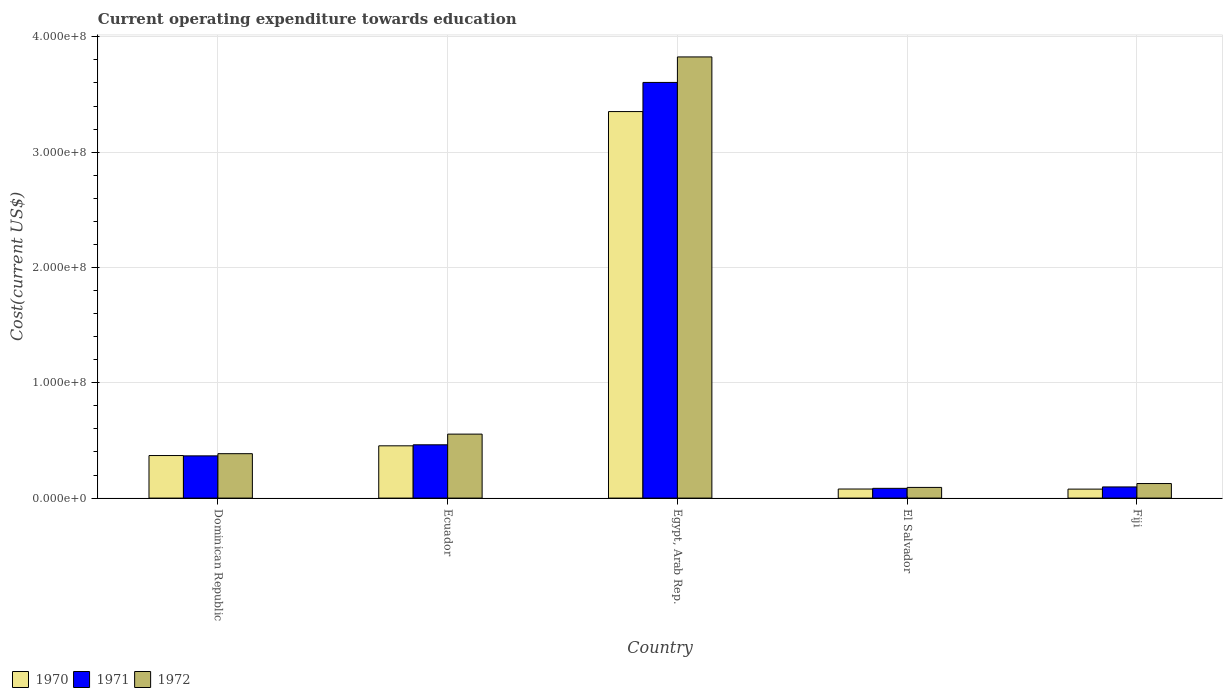Are the number of bars on each tick of the X-axis equal?
Provide a short and direct response. Yes. How many bars are there on the 3rd tick from the right?
Your answer should be very brief. 3. What is the label of the 5th group of bars from the left?
Your answer should be very brief. Fiji. In how many cases, is the number of bars for a given country not equal to the number of legend labels?
Keep it short and to the point. 0. What is the expenditure towards education in 1972 in Egypt, Arab Rep.?
Your answer should be very brief. 3.83e+08. Across all countries, what is the maximum expenditure towards education in 1970?
Keep it short and to the point. 3.35e+08. Across all countries, what is the minimum expenditure towards education in 1972?
Provide a short and direct response. 9.26e+06. In which country was the expenditure towards education in 1970 maximum?
Your response must be concise. Egypt, Arab Rep. In which country was the expenditure towards education in 1970 minimum?
Offer a terse response. Fiji. What is the total expenditure towards education in 1970 in the graph?
Your answer should be very brief. 4.33e+08. What is the difference between the expenditure towards education in 1971 in El Salvador and that in Fiji?
Offer a terse response. -1.21e+06. What is the difference between the expenditure towards education in 1970 in Dominican Republic and the expenditure towards education in 1972 in Egypt, Arab Rep.?
Make the answer very short. -3.46e+08. What is the average expenditure towards education in 1972 per country?
Provide a succinct answer. 9.97e+07. What is the difference between the expenditure towards education of/in 1972 and expenditure towards education of/in 1970 in Fiji?
Offer a terse response. 4.84e+06. In how many countries, is the expenditure towards education in 1970 greater than 220000000 US$?
Give a very brief answer. 1. What is the ratio of the expenditure towards education in 1971 in Ecuador to that in Egypt, Arab Rep.?
Provide a succinct answer. 0.13. Is the difference between the expenditure towards education in 1972 in Dominican Republic and Ecuador greater than the difference between the expenditure towards education in 1970 in Dominican Republic and Ecuador?
Offer a very short reply. No. What is the difference between the highest and the second highest expenditure towards education in 1970?
Your answer should be compact. 2.90e+08. What is the difference between the highest and the lowest expenditure towards education in 1971?
Offer a very short reply. 3.52e+08. Is the sum of the expenditure towards education in 1970 in Egypt, Arab Rep. and El Salvador greater than the maximum expenditure towards education in 1971 across all countries?
Ensure brevity in your answer.  No. What does the 1st bar from the left in El Salvador represents?
Your answer should be very brief. 1970. How many countries are there in the graph?
Offer a terse response. 5. What is the difference between two consecutive major ticks on the Y-axis?
Provide a short and direct response. 1.00e+08. What is the title of the graph?
Your response must be concise. Current operating expenditure towards education. Does "1983" appear as one of the legend labels in the graph?
Provide a short and direct response. No. What is the label or title of the X-axis?
Offer a terse response. Country. What is the label or title of the Y-axis?
Provide a succinct answer. Cost(current US$). What is the Cost(current US$) of 1970 in Dominican Republic?
Your response must be concise. 3.69e+07. What is the Cost(current US$) of 1971 in Dominican Republic?
Your response must be concise. 3.66e+07. What is the Cost(current US$) in 1972 in Dominican Republic?
Keep it short and to the point. 3.85e+07. What is the Cost(current US$) of 1970 in Ecuador?
Give a very brief answer. 4.53e+07. What is the Cost(current US$) of 1971 in Ecuador?
Provide a short and direct response. 4.62e+07. What is the Cost(current US$) of 1972 in Ecuador?
Provide a short and direct response. 5.55e+07. What is the Cost(current US$) of 1970 in Egypt, Arab Rep.?
Offer a terse response. 3.35e+08. What is the Cost(current US$) of 1971 in Egypt, Arab Rep.?
Provide a short and direct response. 3.60e+08. What is the Cost(current US$) of 1972 in Egypt, Arab Rep.?
Make the answer very short. 3.83e+08. What is the Cost(current US$) in 1970 in El Salvador?
Offer a terse response. 7.86e+06. What is the Cost(current US$) in 1971 in El Salvador?
Your answer should be very brief. 8.46e+06. What is the Cost(current US$) in 1972 in El Salvador?
Offer a terse response. 9.26e+06. What is the Cost(current US$) in 1970 in Fiji?
Your answer should be compact. 7.79e+06. What is the Cost(current US$) of 1971 in Fiji?
Make the answer very short. 9.67e+06. What is the Cost(current US$) in 1972 in Fiji?
Your response must be concise. 1.26e+07. Across all countries, what is the maximum Cost(current US$) of 1970?
Provide a succinct answer. 3.35e+08. Across all countries, what is the maximum Cost(current US$) of 1971?
Offer a very short reply. 3.60e+08. Across all countries, what is the maximum Cost(current US$) of 1972?
Your response must be concise. 3.83e+08. Across all countries, what is the minimum Cost(current US$) of 1970?
Provide a short and direct response. 7.79e+06. Across all countries, what is the minimum Cost(current US$) in 1971?
Provide a short and direct response. 8.46e+06. Across all countries, what is the minimum Cost(current US$) in 1972?
Ensure brevity in your answer.  9.26e+06. What is the total Cost(current US$) in 1970 in the graph?
Your response must be concise. 4.33e+08. What is the total Cost(current US$) of 1971 in the graph?
Offer a very short reply. 4.61e+08. What is the total Cost(current US$) in 1972 in the graph?
Your answer should be compact. 4.98e+08. What is the difference between the Cost(current US$) in 1970 in Dominican Republic and that in Ecuador?
Make the answer very short. -8.43e+06. What is the difference between the Cost(current US$) of 1971 in Dominican Republic and that in Ecuador?
Provide a succinct answer. -9.60e+06. What is the difference between the Cost(current US$) of 1972 in Dominican Republic and that in Ecuador?
Your answer should be very brief. -1.70e+07. What is the difference between the Cost(current US$) of 1970 in Dominican Republic and that in Egypt, Arab Rep.?
Provide a short and direct response. -2.98e+08. What is the difference between the Cost(current US$) of 1971 in Dominican Republic and that in Egypt, Arab Rep.?
Provide a succinct answer. -3.24e+08. What is the difference between the Cost(current US$) of 1972 in Dominican Republic and that in Egypt, Arab Rep.?
Offer a terse response. -3.44e+08. What is the difference between the Cost(current US$) of 1970 in Dominican Republic and that in El Salvador?
Provide a short and direct response. 2.90e+07. What is the difference between the Cost(current US$) of 1971 in Dominican Republic and that in El Salvador?
Your answer should be compact. 2.82e+07. What is the difference between the Cost(current US$) of 1972 in Dominican Republic and that in El Salvador?
Offer a very short reply. 2.93e+07. What is the difference between the Cost(current US$) in 1970 in Dominican Republic and that in Fiji?
Offer a terse response. 2.91e+07. What is the difference between the Cost(current US$) of 1971 in Dominican Republic and that in Fiji?
Offer a terse response. 2.69e+07. What is the difference between the Cost(current US$) in 1972 in Dominican Republic and that in Fiji?
Provide a short and direct response. 2.59e+07. What is the difference between the Cost(current US$) in 1970 in Ecuador and that in Egypt, Arab Rep.?
Your answer should be very brief. -2.90e+08. What is the difference between the Cost(current US$) in 1971 in Ecuador and that in Egypt, Arab Rep.?
Give a very brief answer. -3.14e+08. What is the difference between the Cost(current US$) of 1972 in Ecuador and that in Egypt, Arab Rep.?
Keep it short and to the point. -3.27e+08. What is the difference between the Cost(current US$) of 1970 in Ecuador and that in El Salvador?
Ensure brevity in your answer.  3.75e+07. What is the difference between the Cost(current US$) in 1971 in Ecuador and that in El Salvador?
Make the answer very short. 3.78e+07. What is the difference between the Cost(current US$) in 1972 in Ecuador and that in El Salvador?
Your response must be concise. 4.62e+07. What is the difference between the Cost(current US$) in 1970 in Ecuador and that in Fiji?
Your answer should be compact. 3.75e+07. What is the difference between the Cost(current US$) of 1971 in Ecuador and that in Fiji?
Make the answer very short. 3.65e+07. What is the difference between the Cost(current US$) of 1972 in Ecuador and that in Fiji?
Offer a terse response. 4.29e+07. What is the difference between the Cost(current US$) in 1970 in Egypt, Arab Rep. and that in El Salvador?
Your response must be concise. 3.27e+08. What is the difference between the Cost(current US$) of 1971 in Egypt, Arab Rep. and that in El Salvador?
Ensure brevity in your answer.  3.52e+08. What is the difference between the Cost(current US$) of 1972 in Egypt, Arab Rep. and that in El Salvador?
Ensure brevity in your answer.  3.73e+08. What is the difference between the Cost(current US$) in 1970 in Egypt, Arab Rep. and that in Fiji?
Ensure brevity in your answer.  3.27e+08. What is the difference between the Cost(current US$) in 1971 in Egypt, Arab Rep. and that in Fiji?
Keep it short and to the point. 3.51e+08. What is the difference between the Cost(current US$) of 1972 in Egypt, Arab Rep. and that in Fiji?
Provide a succinct answer. 3.70e+08. What is the difference between the Cost(current US$) in 1970 in El Salvador and that in Fiji?
Offer a very short reply. 7.56e+04. What is the difference between the Cost(current US$) of 1971 in El Salvador and that in Fiji?
Offer a very short reply. -1.21e+06. What is the difference between the Cost(current US$) of 1972 in El Salvador and that in Fiji?
Give a very brief answer. -3.37e+06. What is the difference between the Cost(current US$) in 1970 in Dominican Republic and the Cost(current US$) in 1971 in Ecuador?
Provide a succinct answer. -9.31e+06. What is the difference between the Cost(current US$) in 1970 in Dominican Republic and the Cost(current US$) in 1972 in Ecuador?
Offer a terse response. -1.86e+07. What is the difference between the Cost(current US$) of 1971 in Dominican Republic and the Cost(current US$) of 1972 in Ecuador?
Offer a very short reply. -1.89e+07. What is the difference between the Cost(current US$) in 1970 in Dominican Republic and the Cost(current US$) in 1971 in Egypt, Arab Rep.?
Make the answer very short. -3.24e+08. What is the difference between the Cost(current US$) in 1970 in Dominican Republic and the Cost(current US$) in 1972 in Egypt, Arab Rep.?
Offer a very short reply. -3.46e+08. What is the difference between the Cost(current US$) in 1971 in Dominican Republic and the Cost(current US$) in 1972 in Egypt, Arab Rep.?
Offer a very short reply. -3.46e+08. What is the difference between the Cost(current US$) of 1970 in Dominican Republic and the Cost(current US$) of 1971 in El Salvador?
Offer a terse response. 2.84e+07. What is the difference between the Cost(current US$) of 1970 in Dominican Republic and the Cost(current US$) of 1972 in El Salvador?
Offer a terse response. 2.76e+07. What is the difference between the Cost(current US$) in 1971 in Dominican Republic and the Cost(current US$) in 1972 in El Salvador?
Offer a terse response. 2.74e+07. What is the difference between the Cost(current US$) in 1970 in Dominican Republic and the Cost(current US$) in 1971 in Fiji?
Your response must be concise. 2.72e+07. What is the difference between the Cost(current US$) in 1970 in Dominican Republic and the Cost(current US$) in 1972 in Fiji?
Keep it short and to the point. 2.43e+07. What is the difference between the Cost(current US$) in 1971 in Dominican Republic and the Cost(current US$) in 1972 in Fiji?
Offer a terse response. 2.40e+07. What is the difference between the Cost(current US$) of 1970 in Ecuador and the Cost(current US$) of 1971 in Egypt, Arab Rep.?
Your answer should be very brief. -3.15e+08. What is the difference between the Cost(current US$) of 1970 in Ecuador and the Cost(current US$) of 1972 in Egypt, Arab Rep.?
Your response must be concise. -3.37e+08. What is the difference between the Cost(current US$) of 1971 in Ecuador and the Cost(current US$) of 1972 in Egypt, Arab Rep.?
Offer a very short reply. -3.36e+08. What is the difference between the Cost(current US$) in 1970 in Ecuador and the Cost(current US$) in 1971 in El Salvador?
Offer a very short reply. 3.69e+07. What is the difference between the Cost(current US$) in 1970 in Ecuador and the Cost(current US$) in 1972 in El Salvador?
Ensure brevity in your answer.  3.61e+07. What is the difference between the Cost(current US$) in 1971 in Ecuador and the Cost(current US$) in 1972 in El Salvador?
Your response must be concise. 3.70e+07. What is the difference between the Cost(current US$) of 1970 in Ecuador and the Cost(current US$) of 1971 in Fiji?
Give a very brief answer. 3.57e+07. What is the difference between the Cost(current US$) of 1970 in Ecuador and the Cost(current US$) of 1972 in Fiji?
Offer a terse response. 3.27e+07. What is the difference between the Cost(current US$) in 1971 in Ecuador and the Cost(current US$) in 1972 in Fiji?
Keep it short and to the point. 3.36e+07. What is the difference between the Cost(current US$) of 1970 in Egypt, Arab Rep. and the Cost(current US$) of 1971 in El Salvador?
Your response must be concise. 3.27e+08. What is the difference between the Cost(current US$) in 1970 in Egypt, Arab Rep. and the Cost(current US$) in 1972 in El Salvador?
Offer a very short reply. 3.26e+08. What is the difference between the Cost(current US$) in 1971 in Egypt, Arab Rep. and the Cost(current US$) in 1972 in El Salvador?
Offer a terse response. 3.51e+08. What is the difference between the Cost(current US$) of 1970 in Egypt, Arab Rep. and the Cost(current US$) of 1971 in Fiji?
Provide a short and direct response. 3.26e+08. What is the difference between the Cost(current US$) of 1970 in Egypt, Arab Rep. and the Cost(current US$) of 1972 in Fiji?
Your response must be concise. 3.23e+08. What is the difference between the Cost(current US$) of 1971 in Egypt, Arab Rep. and the Cost(current US$) of 1972 in Fiji?
Your answer should be compact. 3.48e+08. What is the difference between the Cost(current US$) in 1970 in El Salvador and the Cost(current US$) in 1971 in Fiji?
Provide a short and direct response. -1.81e+06. What is the difference between the Cost(current US$) of 1970 in El Salvador and the Cost(current US$) of 1972 in Fiji?
Offer a terse response. -4.76e+06. What is the difference between the Cost(current US$) of 1971 in El Salvador and the Cost(current US$) of 1972 in Fiji?
Your answer should be very brief. -4.16e+06. What is the average Cost(current US$) in 1970 per country?
Your answer should be compact. 8.66e+07. What is the average Cost(current US$) of 1971 per country?
Provide a short and direct response. 9.23e+07. What is the average Cost(current US$) of 1972 per country?
Your answer should be very brief. 9.97e+07. What is the difference between the Cost(current US$) in 1970 and Cost(current US$) in 1971 in Dominican Republic?
Provide a short and direct response. 2.90e+05. What is the difference between the Cost(current US$) in 1970 and Cost(current US$) in 1972 in Dominican Republic?
Provide a short and direct response. -1.61e+06. What is the difference between the Cost(current US$) of 1971 and Cost(current US$) of 1972 in Dominican Republic?
Your response must be concise. -1.90e+06. What is the difference between the Cost(current US$) in 1970 and Cost(current US$) in 1971 in Ecuador?
Your answer should be compact. -8.82e+05. What is the difference between the Cost(current US$) of 1970 and Cost(current US$) of 1972 in Ecuador?
Your answer should be compact. -1.02e+07. What is the difference between the Cost(current US$) in 1971 and Cost(current US$) in 1972 in Ecuador?
Offer a terse response. -9.27e+06. What is the difference between the Cost(current US$) of 1970 and Cost(current US$) of 1971 in Egypt, Arab Rep.?
Keep it short and to the point. -2.53e+07. What is the difference between the Cost(current US$) in 1970 and Cost(current US$) in 1972 in Egypt, Arab Rep.?
Your answer should be compact. -4.74e+07. What is the difference between the Cost(current US$) of 1971 and Cost(current US$) of 1972 in Egypt, Arab Rep.?
Provide a short and direct response. -2.21e+07. What is the difference between the Cost(current US$) of 1970 and Cost(current US$) of 1971 in El Salvador?
Make the answer very short. -6.00e+05. What is the difference between the Cost(current US$) in 1970 and Cost(current US$) in 1972 in El Salvador?
Offer a very short reply. -1.39e+06. What is the difference between the Cost(current US$) of 1971 and Cost(current US$) of 1972 in El Salvador?
Give a very brief answer. -7.94e+05. What is the difference between the Cost(current US$) in 1970 and Cost(current US$) in 1971 in Fiji?
Your answer should be compact. -1.89e+06. What is the difference between the Cost(current US$) of 1970 and Cost(current US$) of 1972 in Fiji?
Your answer should be very brief. -4.84e+06. What is the difference between the Cost(current US$) in 1971 and Cost(current US$) in 1972 in Fiji?
Provide a succinct answer. -2.95e+06. What is the ratio of the Cost(current US$) in 1970 in Dominican Republic to that in Ecuador?
Your answer should be compact. 0.81. What is the ratio of the Cost(current US$) in 1971 in Dominican Republic to that in Ecuador?
Provide a succinct answer. 0.79. What is the ratio of the Cost(current US$) in 1972 in Dominican Republic to that in Ecuador?
Your answer should be very brief. 0.69. What is the ratio of the Cost(current US$) in 1970 in Dominican Republic to that in Egypt, Arab Rep.?
Your answer should be very brief. 0.11. What is the ratio of the Cost(current US$) of 1971 in Dominican Republic to that in Egypt, Arab Rep.?
Give a very brief answer. 0.1. What is the ratio of the Cost(current US$) in 1972 in Dominican Republic to that in Egypt, Arab Rep.?
Provide a short and direct response. 0.1. What is the ratio of the Cost(current US$) in 1970 in Dominican Republic to that in El Salvador?
Offer a very short reply. 4.69. What is the ratio of the Cost(current US$) of 1971 in Dominican Republic to that in El Salvador?
Keep it short and to the point. 4.33. What is the ratio of the Cost(current US$) of 1972 in Dominican Republic to that in El Salvador?
Offer a very short reply. 4.16. What is the ratio of the Cost(current US$) in 1970 in Dominican Republic to that in Fiji?
Offer a very short reply. 4.74. What is the ratio of the Cost(current US$) of 1971 in Dominican Republic to that in Fiji?
Provide a short and direct response. 3.79. What is the ratio of the Cost(current US$) of 1972 in Dominican Republic to that in Fiji?
Make the answer very short. 3.05. What is the ratio of the Cost(current US$) of 1970 in Ecuador to that in Egypt, Arab Rep.?
Provide a short and direct response. 0.14. What is the ratio of the Cost(current US$) in 1971 in Ecuador to that in Egypt, Arab Rep.?
Your response must be concise. 0.13. What is the ratio of the Cost(current US$) in 1972 in Ecuador to that in Egypt, Arab Rep.?
Your answer should be very brief. 0.14. What is the ratio of the Cost(current US$) of 1970 in Ecuador to that in El Salvador?
Provide a short and direct response. 5.77. What is the ratio of the Cost(current US$) in 1971 in Ecuador to that in El Salvador?
Give a very brief answer. 5.46. What is the ratio of the Cost(current US$) of 1972 in Ecuador to that in El Salvador?
Offer a very short reply. 5.99. What is the ratio of the Cost(current US$) in 1970 in Ecuador to that in Fiji?
Ensure brevity in your answer.  5.82. What is the ratio of the Cost(current US$) of 1971 in Ecuador to that in Fiji?
Offer a very short reply. 4.78. What is the ratio of the Cost(current US$) in 1972 in Ecuador to that in Fiji?
Offer a terse response. 4.39. What is the ratio of the Cost(current US$) in 1970 in Egypt, Arab Rep. to that in El Salvador?
Your answer should be very brief. 42.63. What is the ratio of the Cost(current US$) of 1971 in Egypt, Arab Rep. to that in El Salvador?
Your response must be concise. 42.59. What is the ratio of the Cost(current US$) in 1972 in Egypt, Arab Rep. to that in El Salvador?
Provide a succinct answer. 41.33. What is the ratio of the Cost(current US$) in 1970 in Egypt, Arab Rep. to that in Fiji?
Your answer should be very brief. 43.04. What is the ratio of the Cost(current US$) of 1971 in Egypt, Arab Rep. to that in Fiji?
Provide a succinct answer. 37.26. What is the ratio of the Cost(current US$) of 1972 in Egypt, Arab Rep. to that in Fiji?
Offer a very short reply. 30.3. What is the ratio of the Cost(current US$) in 1970 in El Salvador to that in Fiji?
Provide a short and direct response. 1.01. What is the ratio of the Cost(current US$) of 1971 in El Salvador to that in Fiji?
Offer a terse response. 0.87. What is the ratio of the Cost(current US$) in 1972 in El Salvador to that in Fiji?
Your answer should be very brief. 0.73. What is the difference between the highest and the second highest Cost(current US$) of 1970?
Offer a very short reply. 2.90e+08. What is the difference between the highest and the second highest Cost(current US$) of 1971?
Offer a terse response. 3.14e+08. What is the difference between the highest and the second highest Cost(current US$) in 1972?
Offer a very short reply. 3.27e+08. What is the difference between the highest and the lowest Cost(current US$) of 1970?
Give a very brief answer. 3.27e+08. What is the difference between the highest and the lowest Cost(current US$) in 1971?
Ensure brevity in your answer.  3.52e+08. What is the difference between the highest and the lowest Cost(current US$) of 1972?
Provide a succinct answer. 3.73e+08. 